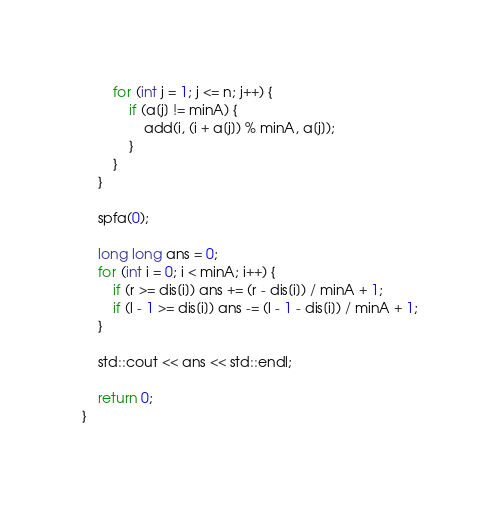<code> <loc_0><loc_0><loc_500><loc_500><_C++_>        for (int j = 1; j <= n; j++) {
            if (a[j] != minA) {
                add(i, (i + a[j]) % minA, a[j]);
            }
        }
    }

    spfa(0);

    long long ans = 0;
    for (int i = 0; i < minA; i++) {
        if (r >= dis[i]) ans += (r - dis[i]) / minA + 1;
        if (l - 1 >= dis[i]) ans -= (l - 1 - dis[i]) / minA + 1;
    }

    std::cout << ans << std::endl;

    return 0;
}</code> 